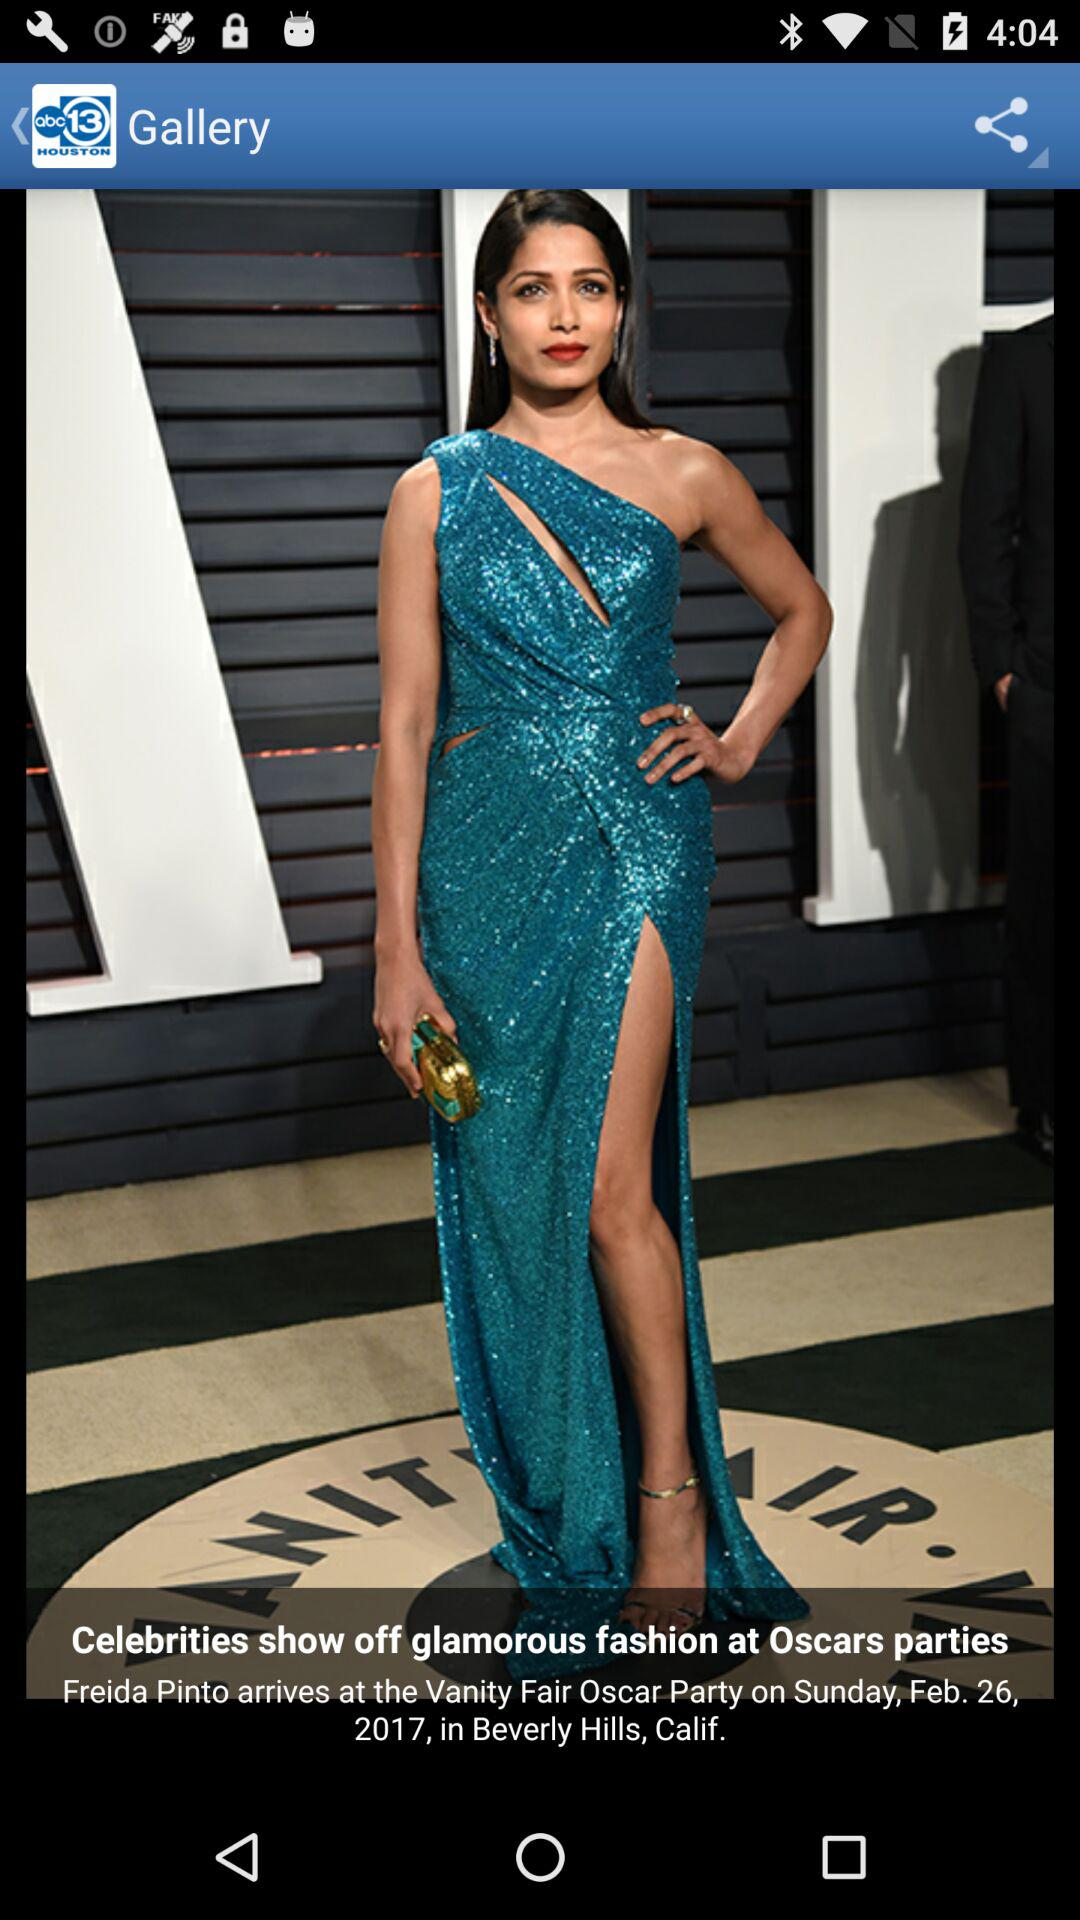What is the venue of the "Oscar Party"? The venue of the "Oscar Party" is Beverly Hills, California. 